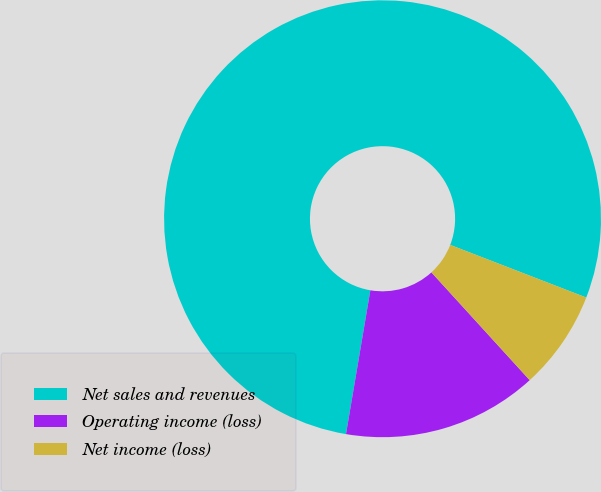Convert chart. <chart><loc_0><loc_0><loc_500><loc_500><pie_chart><fcel>Net sales and revenues<fcel>Operating income (loss)<fcel>Net income (loss)<nl><fcel>78.2%<fcel>14.44%<fcel>7.36%<nl></chart> 